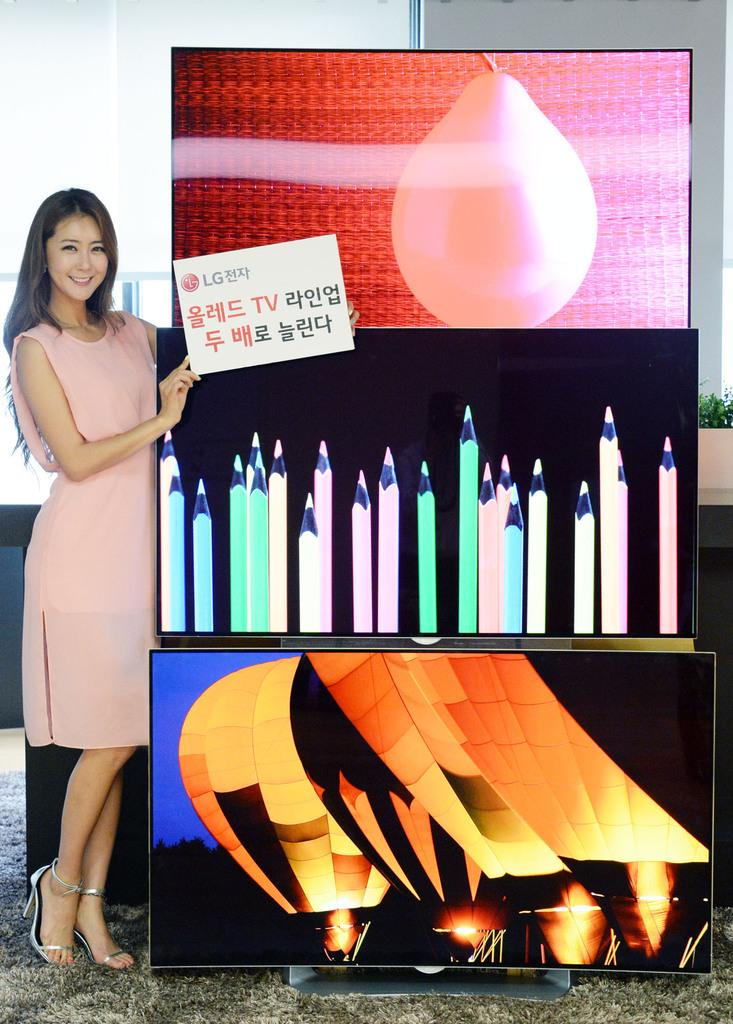What is located in the front of the image? There are banners in the front of the image. Who is present in the image? There is a woman in the image. What is the woman wearing? The woman is wearing a pink dress. What can be seen in the background of the image? There is a white color wall in the background of the image. What type of plastic is being used for the woman's treatment in the image? There is no indication of any treatment or plastic in the image; it features a woman wearing a pink dress with banners in the front and a white wall in the background. 